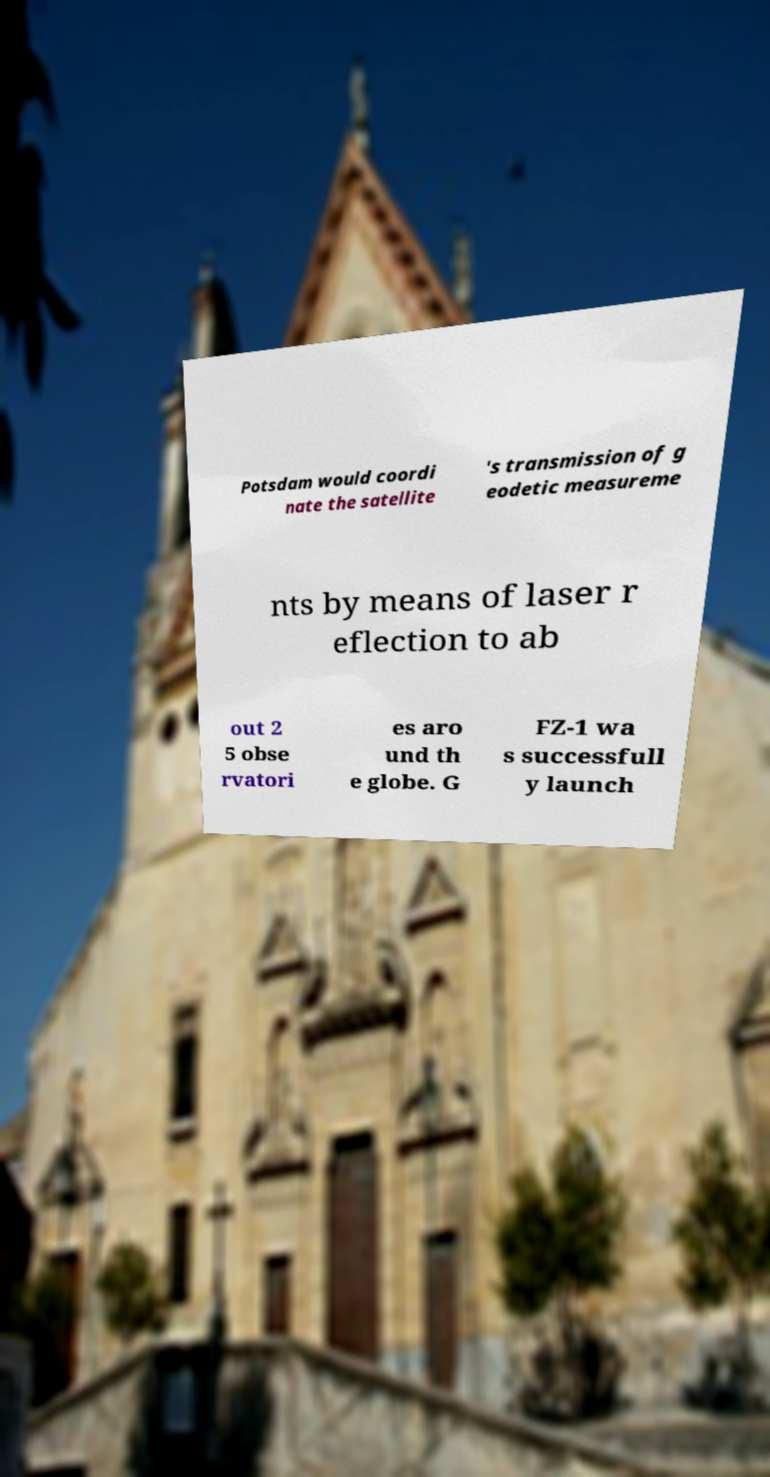Can you read and provide the text displayed in the image?This photo seems to have some interesting text. Can you extract and type it out for me? Potsdam would coordi nate the satellite 's transmission of g eodetic measureme nts by means of laser r eflection to ab out 2 5 obse rvatori es aro und th e globe. G FZ-1 wa s successfull y launch 